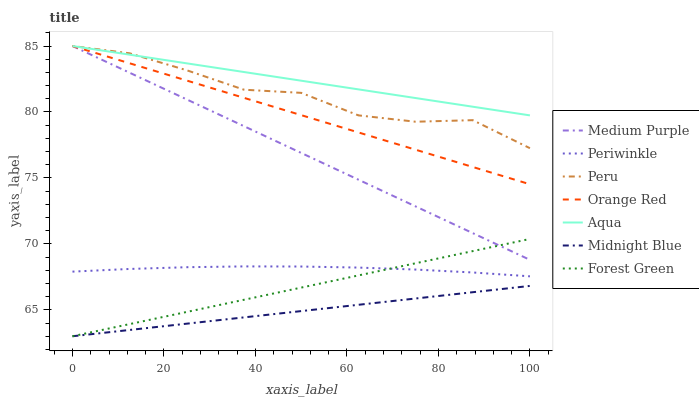Does Midnight Blue have the minimum area under the curve?
Answer yes or no. Yes. Does Aqua have the maximum area under the curve?
Answer yes or no. Yes. Does Medium Purple have the minimum area under the curve?
Answer yes or no. No. Does Medium Purple have the maximum area under the curve?
Answer yes or no. No. Is Aqua the smoothest?
Answer yes or no. Yes. Is Peru the roughest?
Answer yes or no. Yes. Is Medium Purple the smoothest?
Answer yes or no. No. Is Medium Purple the roughest?
Answer yes or no. No. Does Midnight Blue have the lowest value?
Answer yes or no. Yes. Does Medium Purple have the lowest value?
Answer yes or no. No. Does Orange Red have the highest value?
Answer yes or no. Yes. Does Forest Green have the highest value?
Answer yes or no. No. Is Midnight Blue less than Peru?
Answer yes or no. Yes. Is Medium Purple greater than Periwinkle?
Answer yes or no. Yes. Does Peru intersect Medium Purple?
Answer yes or no. Yes. Is Peru less than Medium Purple?
Answer yes or no. No. Is Peru greater than Medium Purple?
Answer yes or no. No. Does Midnight Blue intersect Peru?
Answer yes or no. No. 